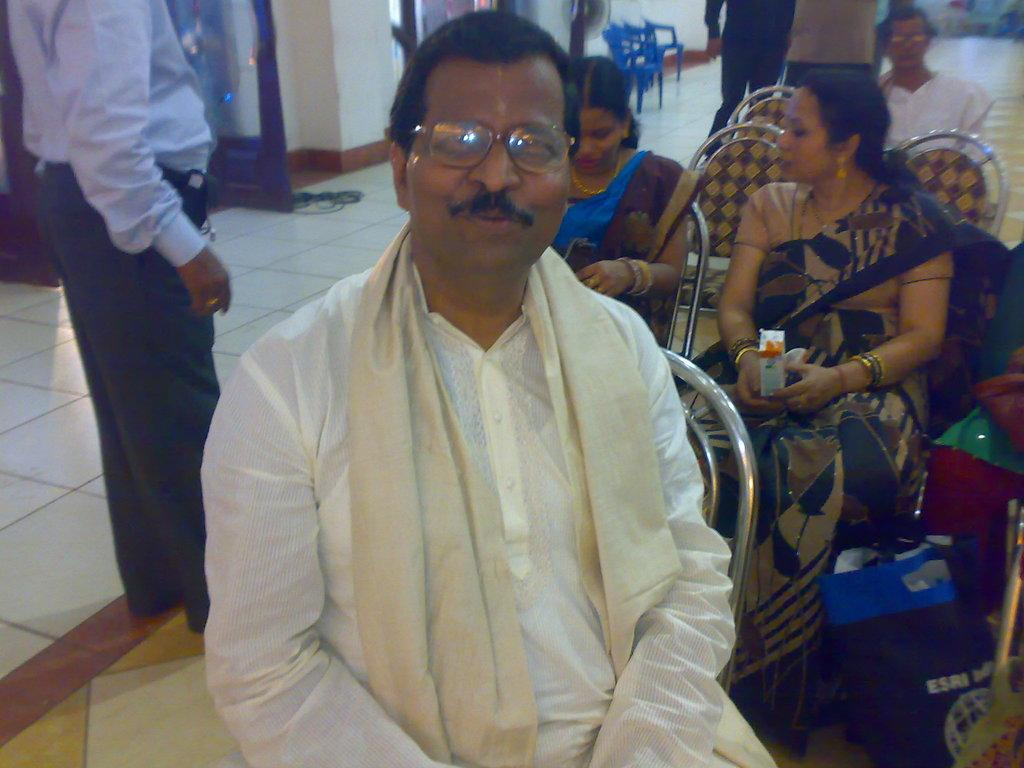What are the people in the image doing? The people in the image are sitting on chairs. Can you describe the man on the left side of the image? There is a man standing on the left side of the image. How many people are standing in the image? There are two people standing in the image. What is the color of the empty chairs in the image? The empty chairs in the image are blue. Can you tell me how many goldfish are swimming in the image? There are no goldfish present in the image. What type of event is taking place in the image? The image does not depict any specific event; it simply shows people sitting and standing. 